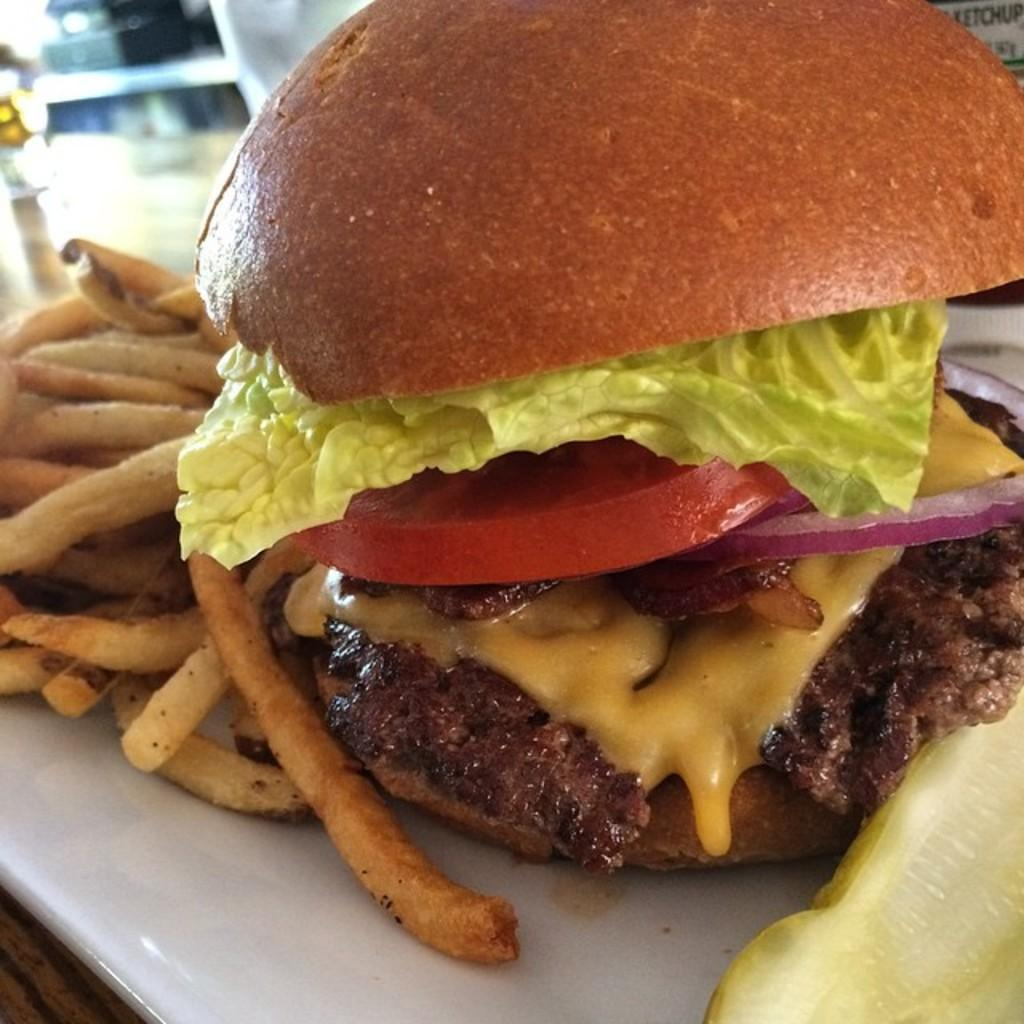What is on the plate that is visible in the image? There is a plate with food in the image, and specifically, there are fries on the plate. What is the plate placed on in the image? The plate is on a wooden platform in the image. Can you describe the background of the image? The background of the image is blurry. How much payment is required for the yam in the image? There is no yam present in the image, so it is not possible to determine any payment required. 